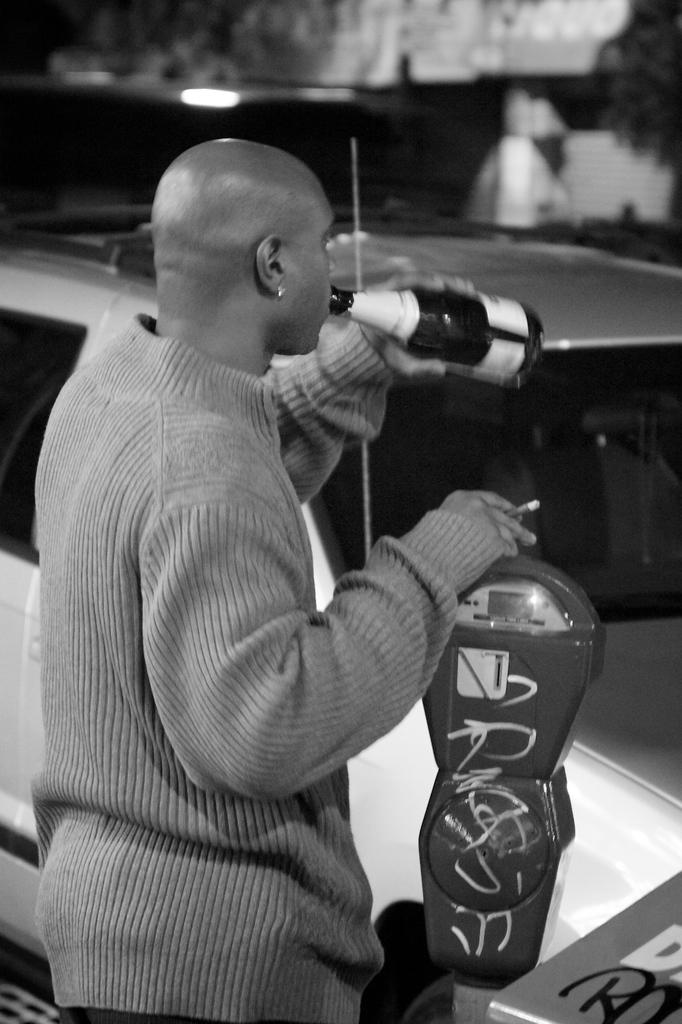What is the main subject of the image? There is a person in the image. What is the person doing in the image? The person is standing and drinking. What else is the person holding in the image? The person is holding a cigarette. What is in front of the person in the image? There is a vehicle in front of the person. What type of seed can be seen growing in the cave behind the person? There is no cave or seed present in the image. How many oranges are visible on the vehicle in front of the person? There are no oranges visible on the vehicle in front of the person. 